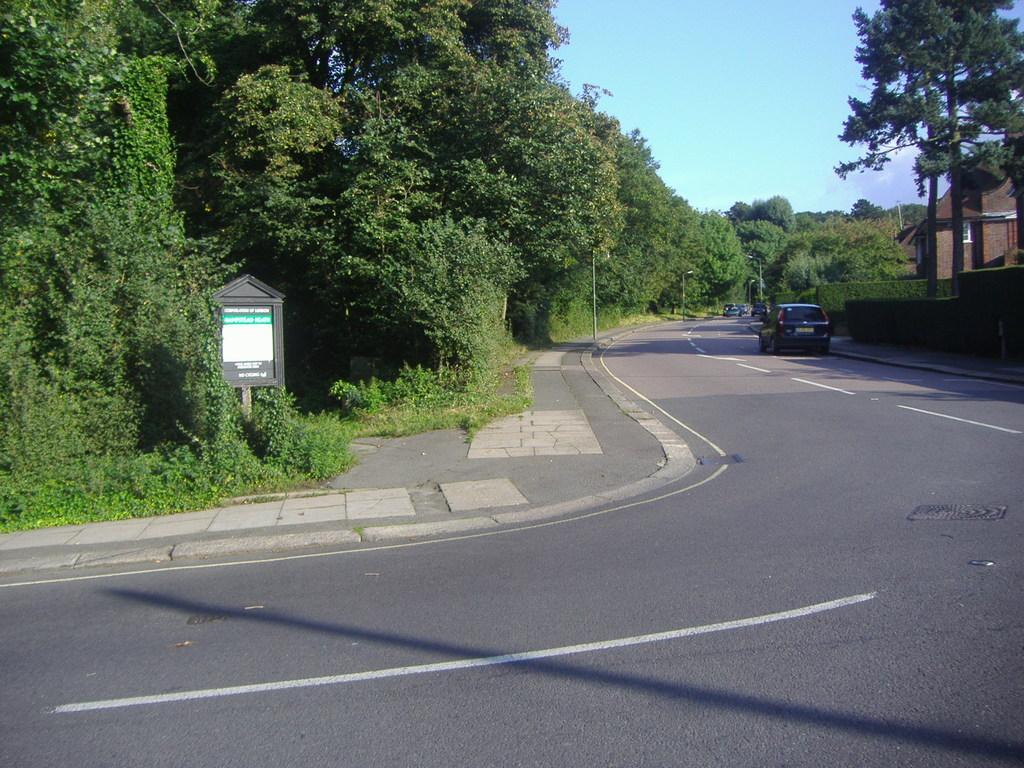Can you describe this image briefly? In this image there are cars on the road. Beside the road there are lamp posts. There is a board with some text on it. There are trees, buildings, bushes. At the top of the image there is sky. 